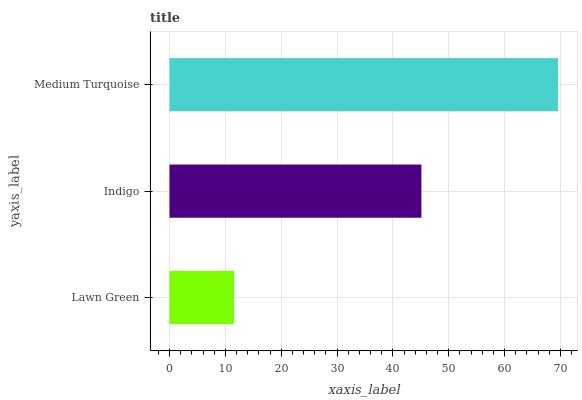Is Lawn Green the minimum?
Answer yes or no. Yes. Is Medium Turquoise the maximum?
Answer yes or no. Yes. Is Indigo the minimum?
Answer yes or no. No. Is Indigo the maximum?
Answer yes or no. No. Is Indigo greater than Lawn Green?
Answer yes or no. Yes. Is Lawn Green less than Indigo?
Answer yes or no. Yes. Is Lawn Green greater than Indigo?
Answer yes or no. No. Is Indigo less than Lawn Green?
Answer yes or no. No. Is Indigo the high median?
Answer yes or no. Yes. Is Indigo the low median?
Answer yes or no. Yes. Is Lawn Green the high median?
Answer yes or no. No. Is Lawn Green the low median?
Answer yes or no. No. 